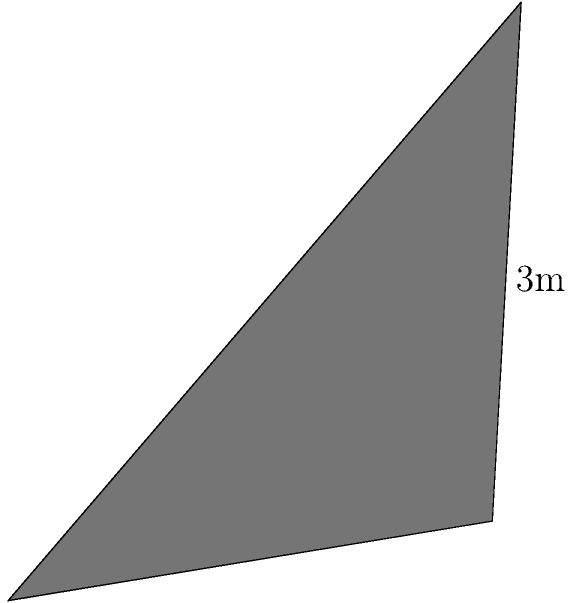A pyramid-shaped memorial structure is being designed to honor the departed members of our community. The base of the pyramid is a rectangle measuring 4 meters by 2 meters, and the height of the pyramid is 3 meters. Calculate the total surface area of this memorial structure, including the base. How might the surface area relate to the concept of collective memory in our communal mourning traditions? Let's approach this step-by-step:

1) First, we need to calculate the area of the base:
   Base area = length × width = $4 \text{ m} \times 2 \text{ m} = 8 \text{ m}^2$

2) Now, we need to calculate the area of each triangular face. There are four faces:
   - Two faces with base 4m
   - Two faces with base 2m

3) For the faces with 4m base:
   Height of the triangle = $\sqrt{3^2 + 1^2} = \sqrt{10} \text{ m}$
   Area of one face = $\frac{1}{2} \times 4 \text{ m} \times \sqrt{10} \text{ m} = 2\sqrt{10} \text{ m}^2$
   Area of two faces = $4\sqrt{10} \text{ m}^2$

4) For the faces with 2m base:
   Height of the triangle = $\sqrt{3^2 + 2^2} = \sqrt{13} \text{ m}$
   Area of one face = $\frac{1}{2} \times 2 \text{ m} \times \sqrt{13} \text{ m} = \sqrt{13} \text{ m}^2$
   Area of two faces = $2\sqrt{13} \text{ m}^2$

5) Total surface area:
   $\text{Surface Area} = \text{Base Area} + \text{Area of all faces}$
   $= 8 + 4\sqrt{10} + 2\sqrt{13} \text{ m}^2$

6) This surface area represents the physical space available for inscriptions, symbols, or artwork that can serve as a focal point for communal mourning and remembrance.
Answer: $8 + 4\sqrt{10} + 2\sqrt{13} \text{ m}^2$ 